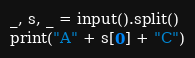<code> <loc_0><loc_0><loc_500><loc_500><_Python_>_, s, _ = input().split()
print("A" + s[0] + "C")
</code> 